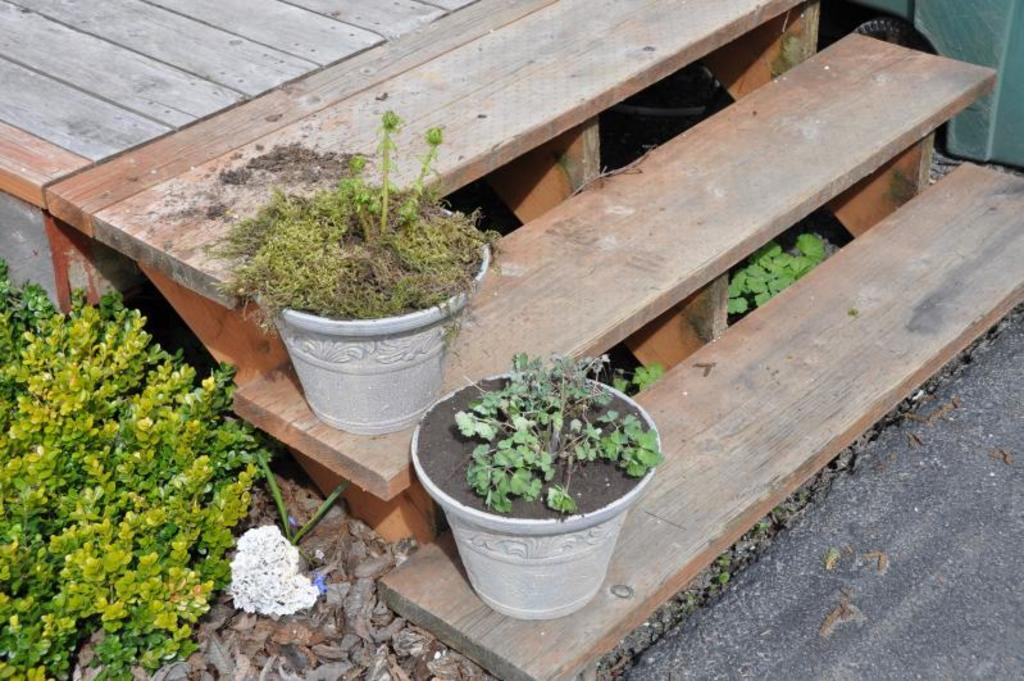What objects are placed on the wooden steps in the image? There are two plant pots on wooden steps in the image. What else can be seen near the plant pots? There is a plant beside the plant pots. What type of material is covering the floor in the image? There are stones on the floor. What is the tax rate for the island depicted in the image? There is no mention of an island or tax rate in the image, so it cannot be determined. 